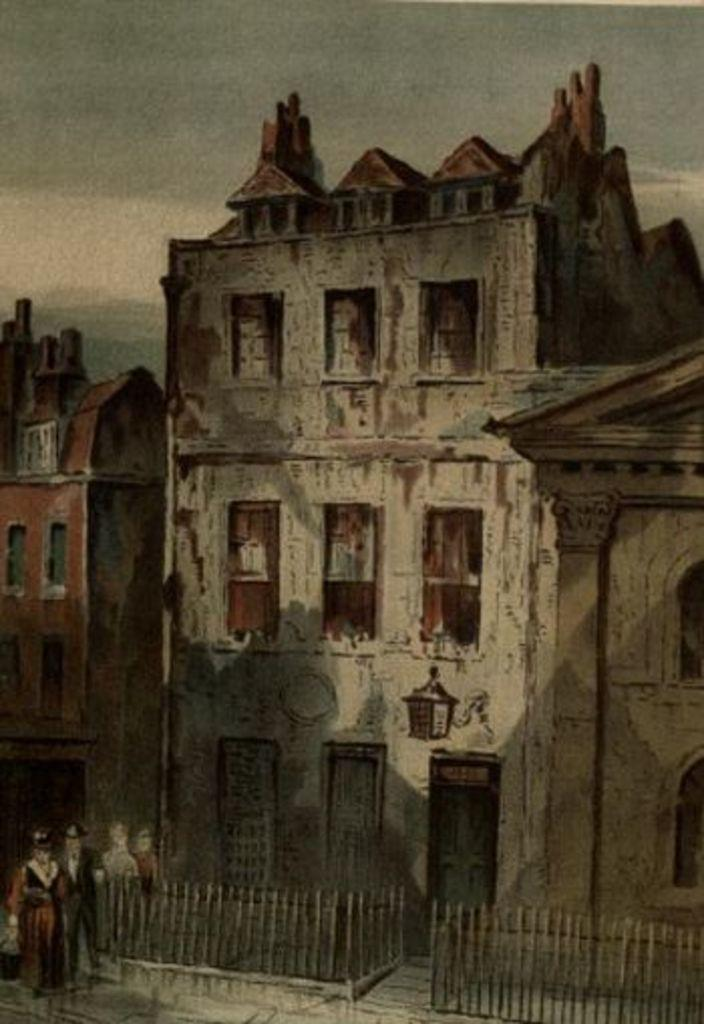What type of artwork is depicted in the image? The image is a painting. What can be seen in the center of the painting? There are buildings in the center of the painting. What is located in front of the buildings? There is a fence in front of the buildings. Are there any people in the painting? Yes, there are persons in the painting. What grade does the person in the painting receive for their performance? There is no indication of a performance or a grade in the painting. The image is a painting of buildings, a fence, and persons, but it does not depict any educational context or evaluation. 